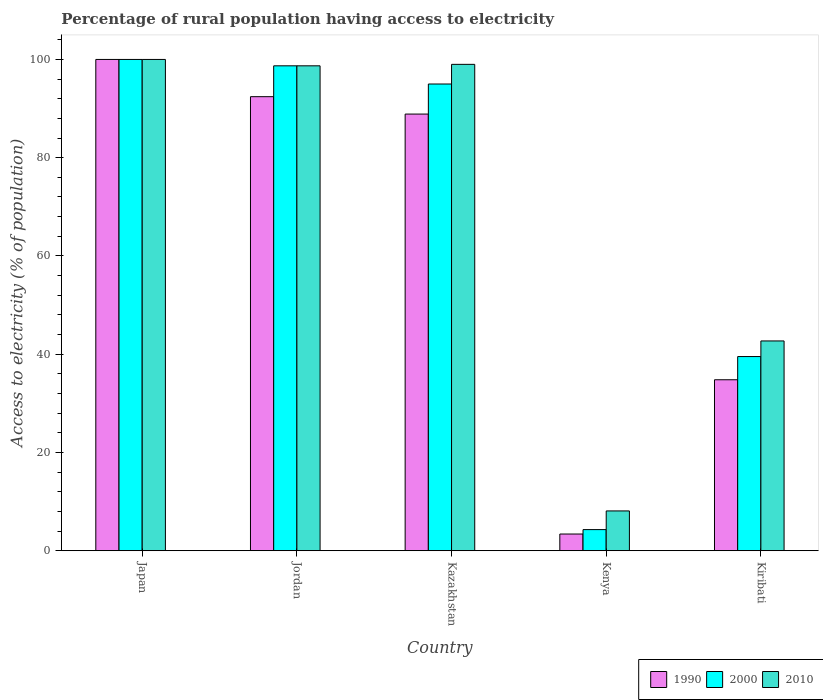How many groups of bars are there?
Provide a succinct answer. 5. Are the number of bars per tick equal to the number of legend labels?
Give a very brief answer. Yes. Are the number of bars on each tick of the X-axis equal?
Provide a short and direct response. Yes. How many bars are there on the 2nd tick from the left?
Keep it short and to the point. 3. How many bars are there on the 4th tick from the right?
Ensure brevity in your answer.  3. What is the label of the 4th group of bars from the left?
Offer a terse response. Kenya. In how many cases, is the number of bars for a given country not equal to the number of legend labels?
Provide a short and direct response. 0. What is the percentage of rural population having access to electricity in 2010 in Japan?
Make the answer very short. 100. In which country was the percentage of rural population having access to electricity in 2000 maximum?
Offer a terse response. Japan. In which country was the percentage of rural population having access to electricity in 1990 minimum?
Your answer should be very brief. Kenya. What is the total percentage of rural population having access to electricity in 1990 in the graph?
Provide a short and direct response. 319.5. What is the difference between the percentage of rural population having access to electricity in 2010 in Kenya and that in Kiribati?
Offer a very short reply. -34.6. What is the difference between the percentage of rural population having access to electricity in 2000 in Kiribati and the percentage of rural population having access to electricity in 2010 in Kazakhstan?
Give a very brief answer. -59.48. What is the average percentage of rural population having access to electricity in 1990 per country?
Your answer should be compact. 63.9. What is the difference between the percentage of rural population having access to electricity of/in 2000 and percentage of rural population having access to electricity of/in 1990 in Kiribati?
Offer a very short reply. 4.72. What is the ratio of the percentage of rural population having access to electricity in 2010 in Japan to that in Kazakhstan?
Offer a terse response. 1.01. Is the percentage of rural population having access to electricity in 2000 in Japan less than that in Kenya?
Provide a short and direct response. No. What is the difference between the highest and the second highest percentage of rural population having access to electricity in 1990?
Provide a succinct answer. -11.12. What is the difference between the highest and the lowest percentage of rural population having access to electricity in 2000?
Keep it short and to the point. 95.7. In how many countries, is the percentage of rural population having access to electricity in 2010 greater than the average percentage of rural population having access to electricity in 2010 taken over all countries?
Offer a very short reply. 3. What does the 3rd bar from the right in Kenya represents?
Provide a short and direct response. 1990. Are all the bars in the graph horizontal?
Give a very brief answer. No. What is the difference between two consecutive major ticks on the Y-axis?
Provide a short and direct response. 20. Are the values on the major ticks of Y-axis written in scientific E-notation?
Provide a short and direct response. No. Does the graph contain any zero values?
Make the answer very short. No. Does the graph contain grids?
Give a very brief answer. No. Where does the legend appear in the graph?
Keep it short and to the point. Bottom right. What is the title of the graph?
Give a very brief answer. Percentage of rural population having access to electricity. What is the label or title of the X-axis?
Ensure brevity in your answer.  Country. What is the label or title of the Y-axis?
Keep it short and to the point. Access to electricity (% of population). What is the Access to electricity (% of population) of 2000 in Japan?
Provide a short and direct response. 100. What is the Access to electricity (% of population) of 2010 in Japan?
Keep it short and to the point. 100. What is the Access to electricity (% of population) of 1990 in Jordan?
Offer a terse response. 92.42. What is the Access to electricity (% of population) in 2000 in Jordan?
Ensure brevity in your answer.  98.7. What is the Access to electricity (% of population) in 2010 in Jordan?
Offer a terse response. 98.7. What is the Access to electricity (% of population) of 1990 in Kazakhstan?
Make the answer very short. 88.88. What is the Access to electricity (% of population) of 2010 in Kazakhstan?
Provide a short and direct response. 99. What is the Access to electricity (% of population) of 2000 in Kenya?
Make the answer very short. 4.3. What is the Access to electricity (% of population) in 2010 in Kenya?
Ensure brevity in your answer.  8.1. What is the Access to electricity (% of population) in 1990 in Kiribati?
Your answer should be compact. 34.8. What is the Access to electricity (% of population) of 2000 in Kiribati?
Your response must be concise. 39.52. What is the Access to electricity (% of population) of 2010 in Kiribati?
Keep it short and to the point. 42.7. Across all countries, what is the maximum Access to electricity (% of population) in 1990?
Provide a succinct answer. 100. Across all countries, what is the maximum Access to electricity (% of population) in 2000?
Provide a succinct answer. 100. Across all countries, what is the maximum Access to electricity (% of population) in 2010?
Provide a succinct answer. 100. Across all countries, what is the minimum Access to electricity (% of population) of 2010?
Make the answer very short. 8.1. What is the total Access to electricity (% of population) in 1990 in the graph?
Ensure brevity in your answer.  319.5. What is the total Access to electricity (% of population) of 2000 in the graph?
Give a very brief answer. 337.52. What is the total Access to electricity (% of population) in 2010 in the graph?
Provide a short and direct response. 348.5. What is the difference between the Access to electricity (% of population) of 1990 in Japan and that in Jordan?
Your answer should be compact. 7.58. What is the difference between the Access to electricity (% of population) of 2000 in Japan and that in Jordan?
Give a very brief answer. 1.3. What is the difference between the Access to electricity (% of population) in 2010 in Japan and that in Jordan?
Provide a succinct answer. 1.3. What is the difference between the Access to electricity (% of population) of 1990 in Japan and that in Kazakhstan?
Provide a succinct answer. 11.12. What is the difference between the Access to electricity (% of population) in 2000 in Japan and that in Kazakhstan?
Your answer should be very brief. 5. What is the difference between the Access to electricity (% of population) of 1990 in Japan and that in Kenya?
Offer a very short reply. 96.6. What is the difference between the Access to electricity (% of population) of 2000 in Japan and that in Kenya?
Keep it short and to the point. 95.7. What is the difference between the Access to electricity (% of population) in 2010 in Japan and that in Kenya?
Offer a very short reply. 91.9. What is the difference between the Access to electricity (% of population) of 1990 in Japan and that in Kiribati?
Make the answer very short. 65.2. What is the difference between the Access to electricity (% of population) of 2000 in Japan and that in Kiribati?
Provide a succinct answer. 60.48. What is the difference between the Access to electricity (% of population) in 2010 in Japan and that in Kiribati?
Keep it short and to the point. 57.3. What is the difference between the Access to electricity (% of population) of 1990 in Jordan and that in Kazakhstan?
Your answer should be very brief. 3.54. What is the difference between the Access to electricity (% of population) in 2000 in Jordan and that in Kazakhstan?
Offer a terse response. 3.7. What is the difference between the Access to electricity (% of population) of 1990 in Jordan and that in Kenya?
Give a very brief answer. 89.02. What is the difference between the Access to electricity (% of population) in 2000 in Jordan and that in Kenya?
Your response must be concise. 94.4. What is the difference between the Access to electricity (% of population) of 2010 in Jordan and that in Kenya?
Offer a terse response. 90.6. What is the difference between the Access to electricity (% of population) in 1990 in Jordan and that in Kiribati?
Offer a terse response. 57.62. What is the difference between the Access to electricity (% of population) in 2000 in Jordan and that in Kiribati?
Your answer should be very brief. 59.18. What is the difference between the Access to electricity (% of population) in 1990 in Kazakhstan and that in Kenya?
Provide a succinct answer. 85.48. What is the difference between the Access to electricity (% of population) in 2000 in Kazakhstan and that in Kenya?
Provide a succinct answer. 90.7. What is the difference between the Access to electricity (% of population) in 2010 in Kazakhstan and that in Kenya?
Your answer should be compact. 90.9. What is the difference between the Access to electricity (% of population) of 1990 in Kazakhstan and that in Kiribati?
Your response must be concise. 54.08. What is the difference between the Access to electricity (% of population) in 2000 in Kazakhstan and that in Kiribati?
Your response must be concise. 55.48. What is the difference between the Access to electricity (% of population) of 2010 in Kazakhstan and that in Kiribati?
Your answer should be compact. 56.3. What is the difference between the Access to electricity (% of population) in 1990 in Kenya and that in Kiribati?
Ensure brevity in your answer.  -31.4. What is the difference between the Access to electricity (% of population) of 2000 in Kenya and that in Kiribati?
Provide a short and direct response. -35.22. What is the difference between the Access to electricity (% of population) of 2010 in Kenya and that in Kiribati?
Offer a very short reply. -34.6. What is the difference between the Access to electricity (% of population) in 1990 in Japan and the Access to electricity (% of population) in 2010 in Jordan?
Offer a very short reply. 1.3. What is the difference between the Access to electricity (% of population) of 1990 in Japan and the Access to electricity (% of population) of 2000 in Kazakhstan?
Make the answer very short. 5. What is the difference between the Access to electricity (% of population) of 1990 in Japan and the Access to electricity (% of population) of 2010 in Kazakhstan?
Give a very brief answer. 1. What is the difference between the Access to electricity (% of population) of 2000 in Japan and the Access to electricity (% of population) of 2010 in Kazakhstan?
Ensure brevity in your answer.  1. What is the difference between the Access to electricity (% of population) of 1990 in Japan and the Access to electricity (% of population) of 2000 in Kenya?
Provide a succinct answer. 95.7. What is the difference between the Access to electricity (% of population) in 1990 in Japan and the Access to electricity (% of population) in 2010 in Kenya?
Your response must be concise. 91.9. What is the difference between the Access to electricity (% of population) in 2000 in Japan and the Access to electricity (% of population) in 2010 in Kenya?
Your response must be concise. 91.9. What is the difference between the Access to electricity (% of population) in 1990 in Japan and the Access to electricity (% of population) in 2000 in Kiribati?
Ensure brevity in your answer.  60.48. What is the difference between the Access to electricity (% of population) of 1990 in Japan and the Access to electricity (% of population) of 2010 in Kiribati?
Provide a succinct answer. 57.3. What is the difference between the Access to electricity (% of population) in 2000 in Japan and the Access to electricity (% of population) in 2010 in Kiribati?
Your answer should be compact. 57.3. What is the difference between the Access to electricity (% of population) in 1990 in Jordan and the Access to electricity (% of population) in 2000 in Kazakhstan?
Give a very brief answer. -2.58. What is the difference between the Access to electricity (% of population) in 1990 in Jordan and the Access to electricity (% of population) in 2010 in Kazakhstan?
Make the answer very short. -6.58. What is the difference between the Access to electricity (% of population) in 1990 in Jordan and the Access to electricity (% of population) in 2000 in Kenya?
Keep it short and to the point. 88.12. What is the difference between the Access to electricity (% of population) in 1990 in Jordan and the Access to electricity (% of population) in 2010 in Kenya?
Give a very brief answer. 84.32. What is the difference between the Access to electricity (% of population) in 2000 in Jordan and the Access to electricity (% of population) in 2010 in Kenya?
Make the answer very short. 90.6. What is the difference between the Access to electricity (% of population) in 1990 in Jordan and the Access to electricity (% of population) in 2000 in Kiribati?
Make the answer very short. 52.9. What is the difference between the Access to electricity (% of population) in 1990 in Jordan and the Access to electricity (% of population) in 2010 in Kiribati?
Keep it short and to the point. 49.72. What is the difference between the Access to electricity (% of population) in 2000 in Jordan and the Access to electricity (% of population) in 2010 in Kiribati?
Give a very brief answer. 56. What is the difference between the Access to electricity (% of population) of 1990 in Kazakhstan and the Access to electricity (% of population) of 2000 in Kenya?
Your answer should be very brief. 84.58. What is the difference between the Access to electricity (% of population) in 1990 in Kazakhstan and the Access to electricity (% of population) in 2010 in Kenya?
Your response must be concise. 80.78. What is the difference between the Access to electricity (% of population) of 2000 in Kazakhstan and the Access to electricity (% of population) of 2010 in Kenya?
Ensure brevity in your answer.  86.9. What is the difference between the Access to electricity (% of population) of 1990 in Kazakhstan and the Access to electricity (% of population) of 2000 in Kiribati?
Make the answer very short. 49.36. What is the difference between the Access to electricity (% of population) of 1990 in Kazakhstan and the Access to electricity (% of population) of 2010 in Kiribati?
Offer a very short reply. 46.18. What is the difference between the Access to electricity (% of population) of 2000 in Kazakhstan and the Access to electricity (% of population) of 2010 in Kiribati?
Make the answer very short. 52.3. What is the difference between the Access to electricity (% of population) in 1990 in Kenya and the Access to electricity (% of population) in 2000 in Kiribati?
Offer a very short reply. -36.12. What is the difference between the Access to electricity (% of population) in 1990 in Kenya and the Access to electricity (% of population) in 2010 in Kiribati?
Offer a very short reply. -39.3. What is the difference between the Access to electricity (% of population) in 2000 in Kenya and the Access to electricity (% of population) in 2010 in Kiribati?
Provide a short and direct response. -38.4. What is the average Access to electricity (% of population) of 1990 per country?
Provide a succinct answer. 63.9. What is the average Access to electricity (% of population) of 2000 per country?
Give a very brief answer. 67.5. What is the average Access to electricity (% of population) in 2010 per country?
Keep it short and to the point. 69.7. What is the difference between the Access to electricity (% of population) in 1990 and Access to electricity (% of population) in 2010 in Japan?
Offer a terse response. 0. What is the difference between the Access to electricity (% of population) of 2000 and Access to electricity (% of population) of 2010 in Japan?
Provide a short and direct response. 0. What is the difference between the Access to electricity (% of population) in 1990 and Access to electricity (% of population) in 2000 in Jordan?
Your response must be concise. -6.28. What is the difference between the Access to electricity (% of population) in 1990 and Access to electricity (% of population) in 2010 in Jordan?
Your answer should be very brief. -6.28. What is the difference between the Access to electricity (% of population) in 2000 and Access to electricity (% of population) in 2010 in Jordan?
Your answer should be very brief. 0. What is the difference between the Access to electricity (% of population) in 1990 and Access to electricity (% of population) in 2000 in Kazakhstan?
Your answer should be very brief. -6.12. What is the difference between the Access to electricity (% of population) in 1990 and Access to electricity (% of population) in 2010 in Kazakhstan?
Keep it short and to the point. -10.12. What is the difference between the Access to electricity (% of population) in 2000 and Access to electricity (% of population) in 2010 in Kenya?
Your response must be concise. -3.8. What is the difference between the Access to electricity (% of population) in 1990 and Access to electricity (% of population) in 2000 in Kiribati?
Provide a short and direct response. -4.72. What is the difference between the Access to electricity (% of population) in 1990 and Access to electricity (% of population) in 2010 in Kiribati?
Your answer should be compact. -7.9. What is the difference between the Access to electricity (% of population) of 2000 and Access to electricity (% of population) of 2010 in Kiribati?
Provide a succinct answer. -3.18. What is the ratio of the Access to electricity (% of population) in 1990 in Japan to that in Jordan?
Offer a very short reply. 1.08. What is the ratio of the Access to electricity (% of population) of 2000 in Japan to that in Jordan?
Offer a very short reply. 1.01. What is the ratio of the Access to electricity (% of population) of 2010 in Japan to that in Jordan?
Your answer should be compact. 1.01. What is the ratio of the Access to electricity (% of population) of 1990 in Japan to that in Kazakhstan?
Your response must be concise. 1.13. What is the ratio of the Access to electricity (% of population) in 2000 in Japan to that in Kazakhstan?
Offer a terse response. 1.05. What is the ratio of the Access to electricity (% of population) in 2010 in Japan to that in Kazakhstan?
Your answer should be very brief. 1.01. What is the ratio of the Access to electricity (% of population) in 1990 in Japan to that in Kenya?
Keep it short and to the point. 29.41. What is the ratio of the Access to electricity (% of population) of 2000 in Japan to that in Kenya?
Your response must be concise. 23.26. What is the ratio of the Access to electricity (% of population) of 2010 in Japan to that in Kenya?
Give a very brief answer. 12.35. What is the ratio of the Access to electricity (% of population) of 1990 in Japan to that in Kiribati?
Your answer should be very brief. 2.87. What is the ratio of the Access to electricity (% of population) of 2000 in Japan to that in Kiribati?
Your answer should be very brief. 2.53. What is the ratio of the Access to electricity (% of population) of 2010 in Japan to that in Kiribati?
Give a very brief answer. 2.34. What is the ratio of the Access to electricity (% of population) in 1990 in Jordan to that in Kazakhstan?
Your answer should be compact. 1.04. What is the ratio of the Access to electricity (% of population) in 2000 in Jordan to that in Kazakhstan?
Your answer should be compact. 1.04. What is the ratio of the Access to electricity (% of population) in 1990 in Jordan to that in Kenya?
Provide a succinct answer. 27.18. What is the ratio of the Access to electricity (% of population) in 2000 in Jordan to that in Kenya?
Provide a short and direct response. 22.95. What is the ratio of the Access to electricity (% of population) in 2010 in Jordan to that in Kenya?
Your response must be concise. 12.19. What is the ratio of the Access to electricity (% of population) of 1990 in Jordan to that in Kiribati?
Your answer should be very brief. 2.66. What is the ratio of the Access to electricity (% of population) of 2000 in Jordan to that in Kiribati?
Give a very brief answer. 2.5. What is the ratio of the Access to electricity (% of population) in 2010 in Jordan to that in Kiribati?
Give a very brief answer. 2.31. What is the ratio of the Access to electricity (% of population) in 1990 in Kazakhstan to that in Kenya?
Offer a terse response. 26.14. What is the ratio of the Access to electricity (% of population) of 2000 in Kazakhstan to that in Kenya?
Ensure brevity in your answer.  22.09. What is the ratio of the Access to electricity (% of population) of 2010 in Kazakhstan to that in Kenya?
Provide a succinct answer. 12.22. What is the ratio of the Access to electricity (% of population) of 1990 in Kazakhstan to that in Kiribati?
Your response must be concise. 2.55. What is the ratio of the Access to electricity (% of population) of 2000 in Kazakhstan to that in Kiribati?
Your response must be concise. 2.4. What is the ratio of the Access to electricity (% of population) in 2010 in Kazakhstan to that in Kiribati?
Your response must be concise. 2.32. What is the ratio of the Access to electricity (% of population) in 1990 in Kenya to that in Kiribati?
Make the answer very short. 0.1. What is the ratio of the Access to electricity (% of population) of 2000 in Kenya to that in Kiribati?
Keep it short and to the point. 0.11. What is the ratio of the Access to electricity (% of population) of 2010 in Kenya to that in Kiribati?
Your response must be concise. 0.19. What is the difference between the highest and the second highest Access to electricity (% of population) in 1990?
Provide a succinct answer. 7.58. What is the difference between the highest and the second highest Access to electricity (% of population) of 2000?
Offer a terse response. 1.3. What is the difference between the highest and the second highest Access to electricity (% of population) of 2010?
Ensure brevity in your answer.  1. What is the difference between the highest and the lowest Access to electricity (% of population) of 1990?
Give a very brief answer. 96.6. What is the difference between the highest and the lowest Access to electricity (% of population) in 2000?
Keep it short and to the point. 95.7. What is the difference between the highest and the lowest Access to electricity (% of population) in 2010?
Offer a very short reply. 91.9. 